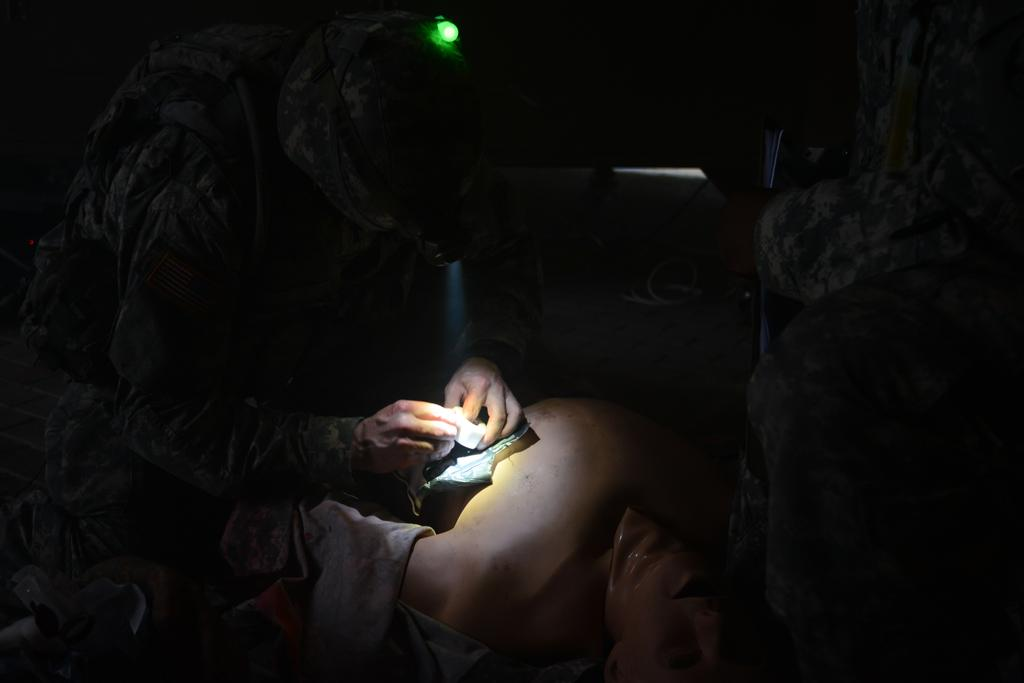What can be seen in the image? There is a person in the image. What is the person wearing? The person is wearing a uniform. What is the person holding? The person is holding some objects. What else does the person have? The person has a bag. What additional accessory is the person wearing? The person is wearing a headlamp. What is visible in the background of the image? There is a rock wall and other objects visible in the background. Can you hear the ghost crying in the image? There is no ghost or crying sound in the image. 